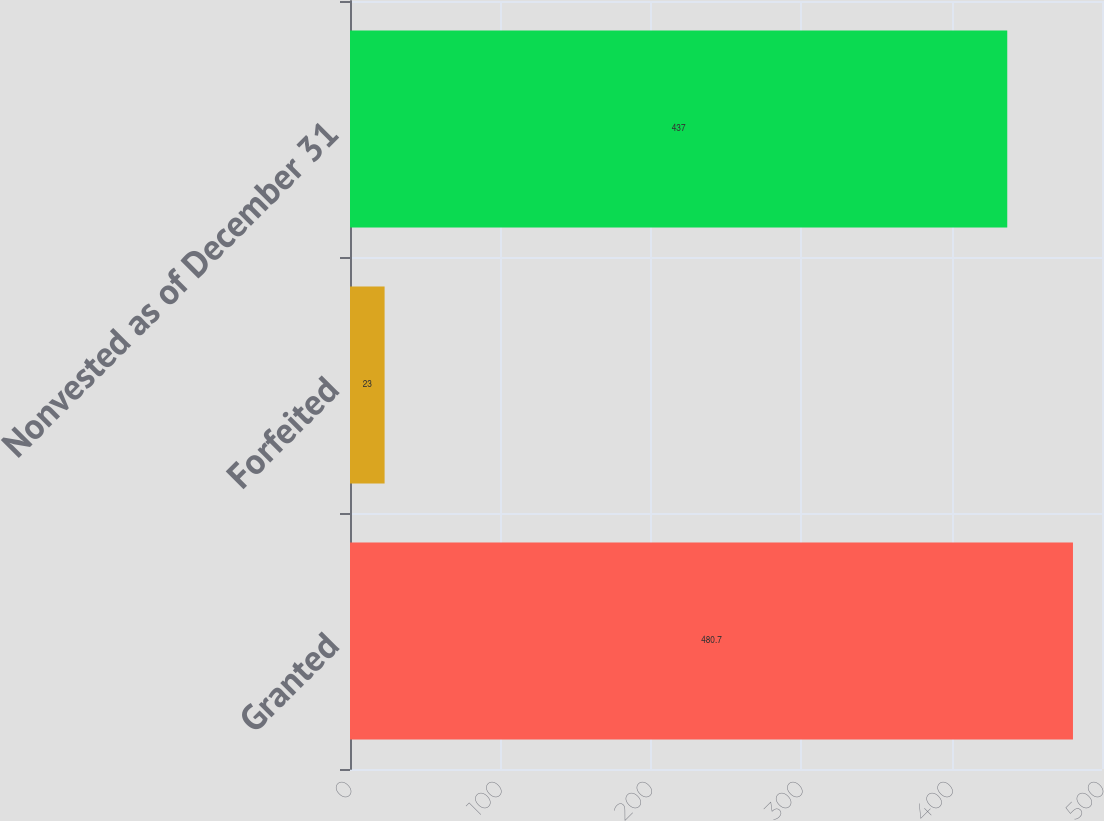Convert chart. <chart><loc_0><loc_0><loc_500><loc_500><bar_chart><fcel>Granted<fcel>Forfeited<fcel>Nonvested as of December 31<nl><fcel>480.7<fcel>23<fcel>437<nl></chart> 